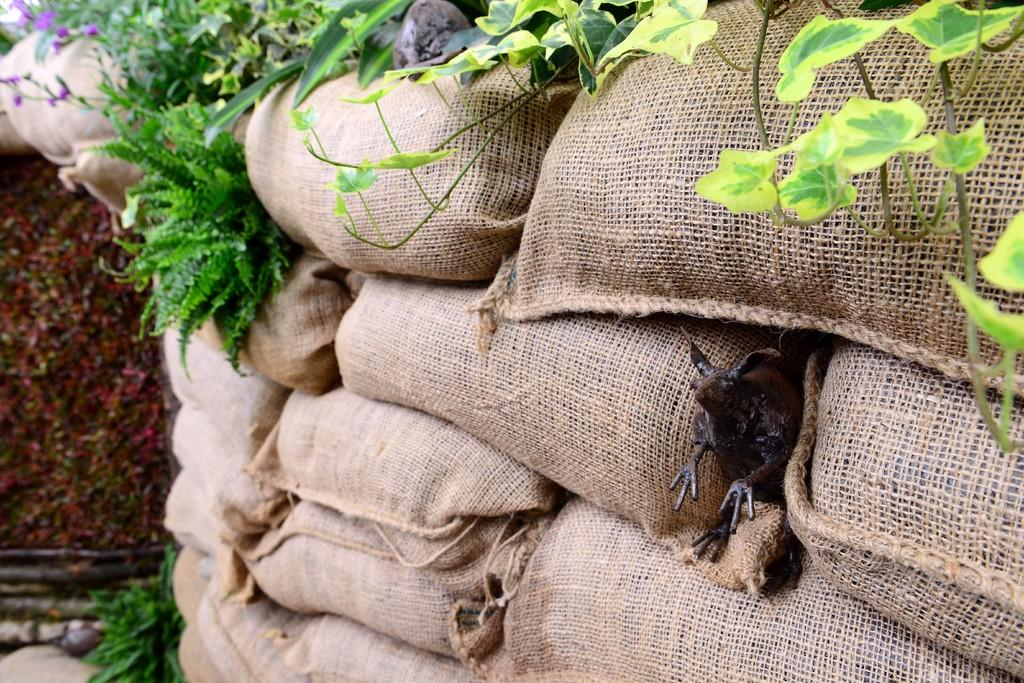What type of bags are present in the image? There are gunny bags in the image. What else can be seen in the image besides the gunny bags? There are plants visible in the image. Can you describe the animal that is visible between the gunny bags? There is an animal visible between the gunny bags, but its specific type cannot be determined from the image. How many bananas are hanging from the linen in the image? There are no bananas or linen present in the image. 